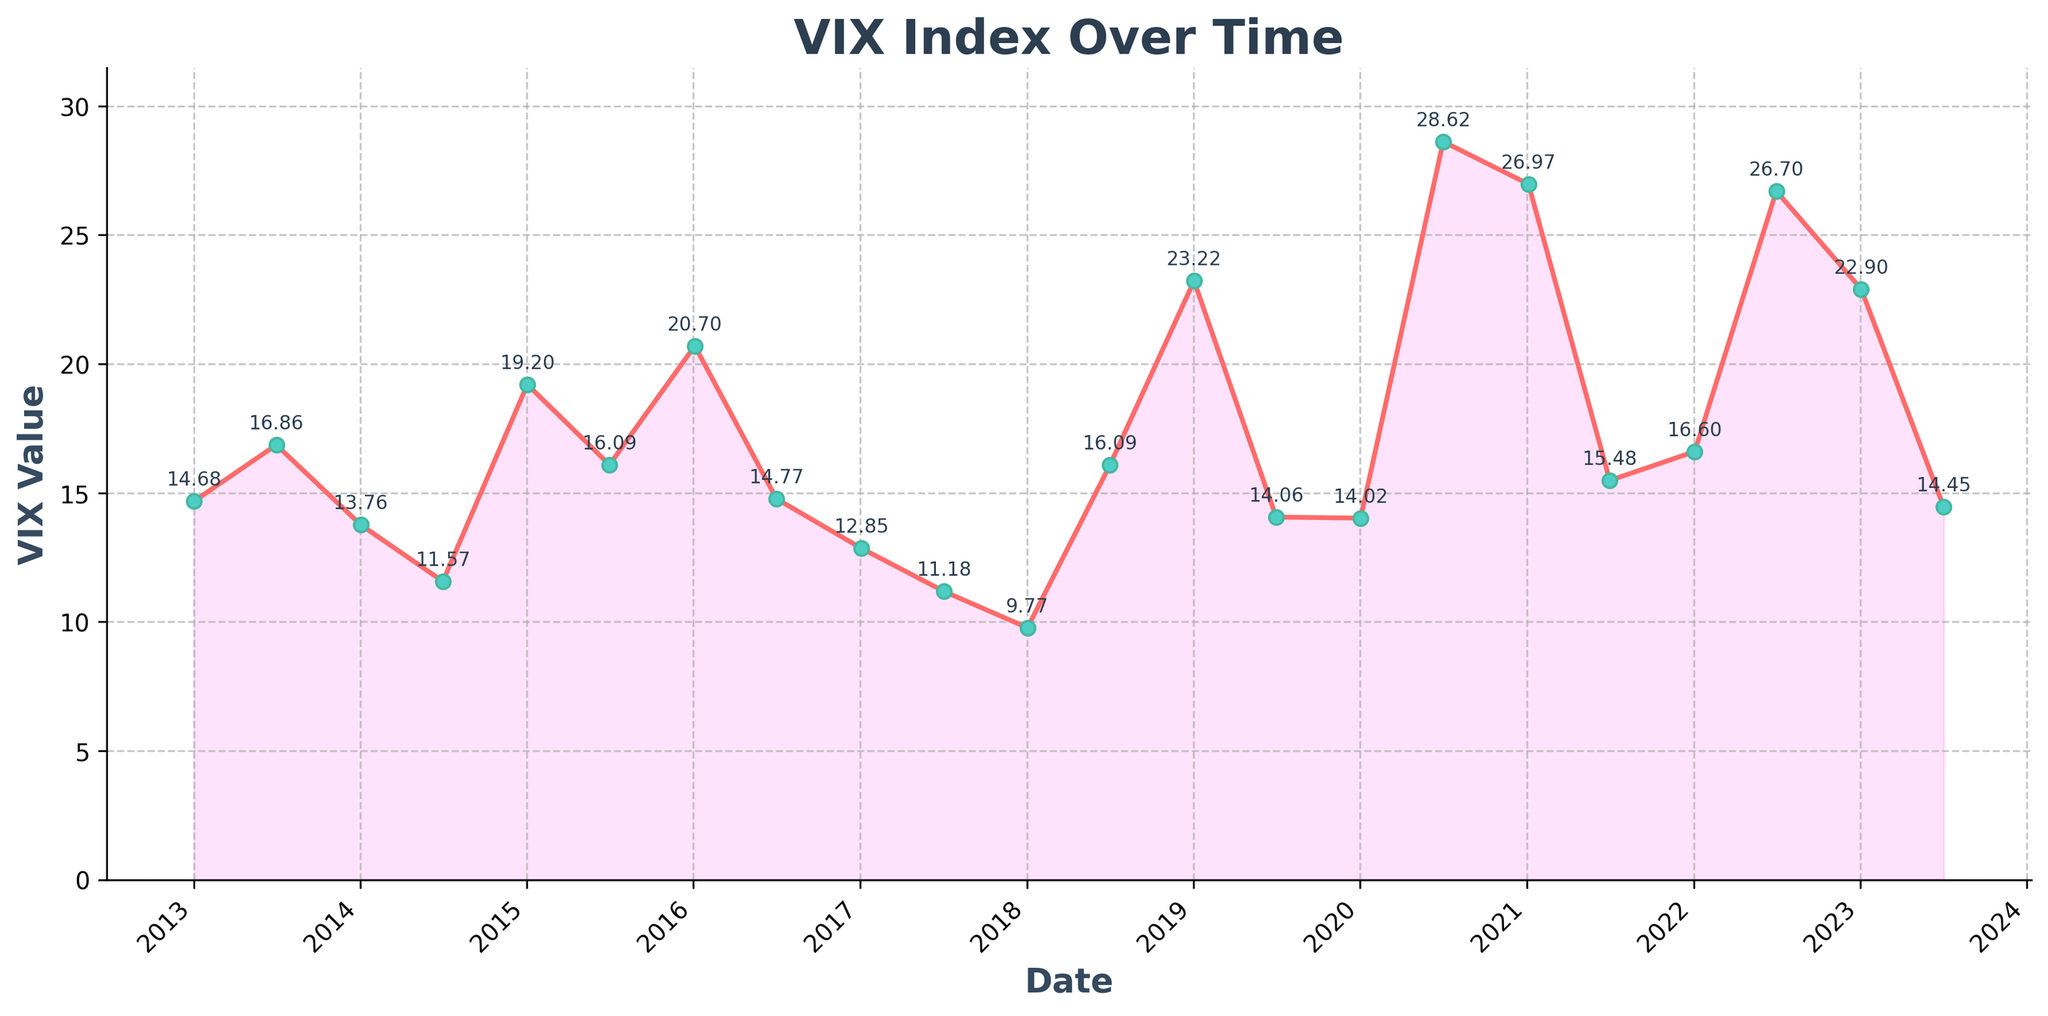What's the highest VIX value observed from 2013 to 2023? Look at the chart and identify the tallest point on the line, which corresponds to the highest VIX value. The highest value is seen around 2020.
Answer: 28.62 Which year had the lowest VIX value, and what was it? Identify the lowest point on the line chart. The lowest value is seen around 2018, just under the 10 mark.
Answer: 2018, 9.77 How does the VIX value on January 2nd, 2020, compare to the value on July 1st, 2020? Compare the height of the markers for these two dates. The value on July 1st, 2020, is significantly higher than on January 2nd, 2020.
Answer: July 1st, 2020 is higher Which year had the most significant increase in VIX from the start of the year to mid-year? Look at the change from January to July for each year. Calculate the differences and identify the largest one. The most significant increase is seen in 2020.
Answer: 2020 What is the average VIX value for the years 2015, 2016, and 2017? Find the VIX values for these years (19.20, 16.09, 20.70, 14.77, 12.85, 11.18). Calculate the sum and divide by the number of values. (19.20 + 16.09 + 20.70 + 14.77 + 12.85 + 11.18) / 6 = 15.47
Answer: 15.47 Did the VIX value ever drop below 10? If yes, when? Scan the chart to see if any values fall below the 10 mark. This occurs in 2018.
Answer: Yes, 2018 What color is used to fill the area under the VIX line? Look at the filled area beneath the line on the chart to identify the color. The fill color is pinkish.
Answer: Pink How does the VIX value on July 3rd, 2017, compare to that on July 1st, 2022? Compare the VIX marker heights for these two dates. The value on July 1st, 2022, is significantly higher.
Answer: July 1st, 2022 is higher What is the median VIX value for the entire dataset? Organize the VIX values in ascending order, find the middle value(s). The median is the middle value once the data is sorted. For this dataset of 22 values, the middle values are the 11th (14.68) and 12th (14.77), and the median is (14.68 + 14.77) / 2 = 14.725.
Answer: 14.725 Which year experienced a decrease in VIX from January to July before significantly increasing by the year-end? Look for years where the VIX value dropped from January to July but ended up higher by year-end. This pattern is visible in 2018.
Answer: 2018 